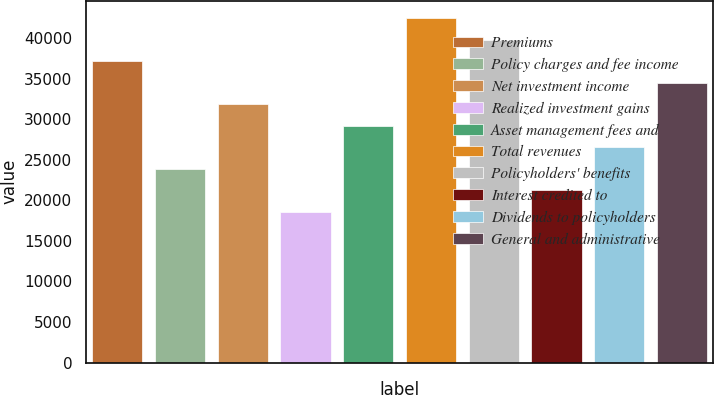Convert chart to OTSL. <chart><loc_0><loc_0><loc_500><loc_500><bar_chart><fcel>Premiums<fcel>Policy charges and fee income<fcel>Net investment income<fcel>Realized investment gains<fcel>Asset management fees and<fcel>Total revenues<fcel>Policyholders' benefits<fcel>Interest credited to<fcel>Dividends to policyholders<fcel>General and administrative<nl><fcel>37150.3<fcel>23882.4<fcel>31843.2<fcel>18575.2<fcel>29189.6<fcel>42457.5<fcel>39803.9<fcel>21228.8<fcel>26536<fcel>34496.7<nl></chart> 